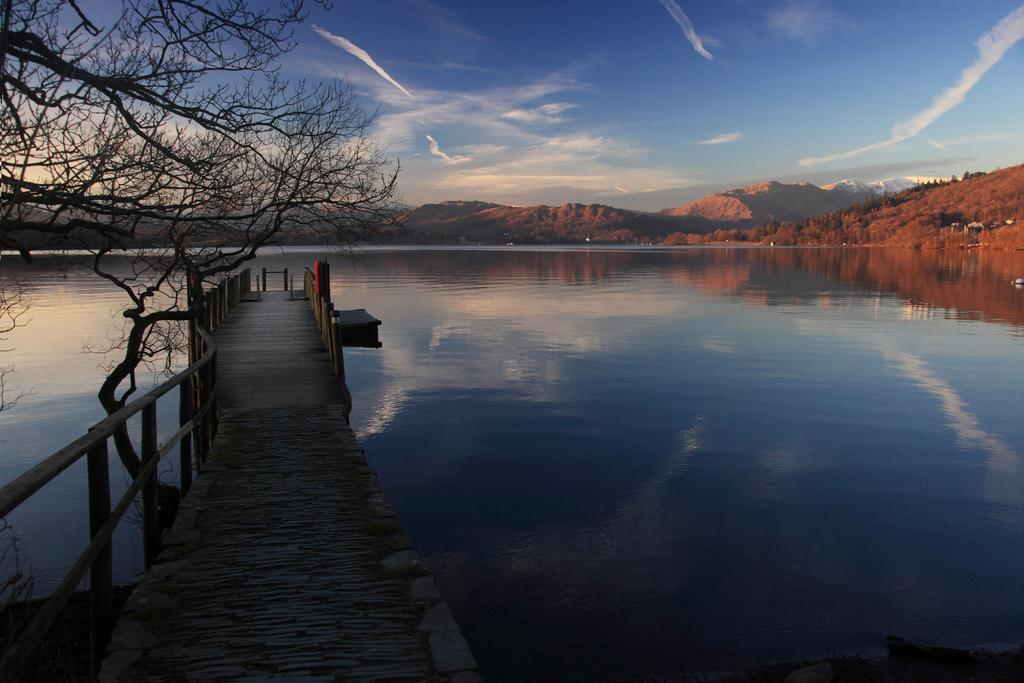What type of structure can be seen in the image? There is a bridge in the image. What other object is present near the bridge? There is a tree beside the bridge in the image. What can be seen in the background of the image? There are mountains and the sky visible in the background of the image. What is the water in the image used for? The water in the image is not explicitly used for anything, but it is likely a river or stream. What type of barrier is present in the image? There is a fence in the image. How many friends are playing volleyball on the bridge in the image? There are no friends or volleyball players present in the image; it only features a bridge, a tree, a fence, water, mountains, and the sky. 